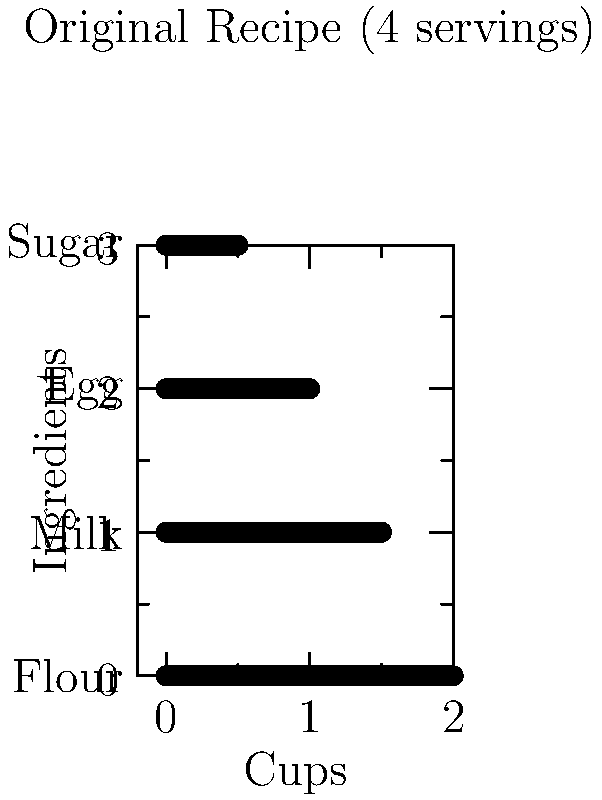You're scaling up your popular pancake recipe for your breakfast blog. The original recipe serves 4 people and is represented by the vector $\mathbf{v} = [2, 1.5, 1, 0.5]$, where each component represents cups of flour, milk, eggs, and sugar respectively. If you want to make pancakes for 10 people, what should the new ingredient vector $\mathbf{v}_{\text{new}}$ be? To scale the recipe from 4 servings to 10 servings, we need to follow these steps:

1) First, calculate the scaling factor:
   $\text{Scaling factor} = \frac{\text{New servings}}{\text{Original servings}} = \frac{10}{4} = 2.5$

2) To get the new ingredient amounts, multiply each component of the original vector by the scaling factor:

   $\mathbf{v}_{\text{new}} = 2.5 \times \mathbf{v}$

3) Let's calculate each component:
   
   Flour: $2.5 \times 2 = 5$ cups
   Milk: $2.5 \times 1.5 = 3.75$ cups
   Eggs: $2.5 \times 1 = 2.5$ cups
   Sugar: $2.5 \times 0.5 = 1.25$ cups

4) Therefore, the new ingredient vector is:

   $\mathbf{v}_{\text{new}} = [5, 3.75, 2.5, 1.25]$

This vector represents the scaled-up recipe for 10 servings.
Answer: $\mathbf{v}_{\text{new}} = [5, 3.75, 2.5, 1.25]$ 